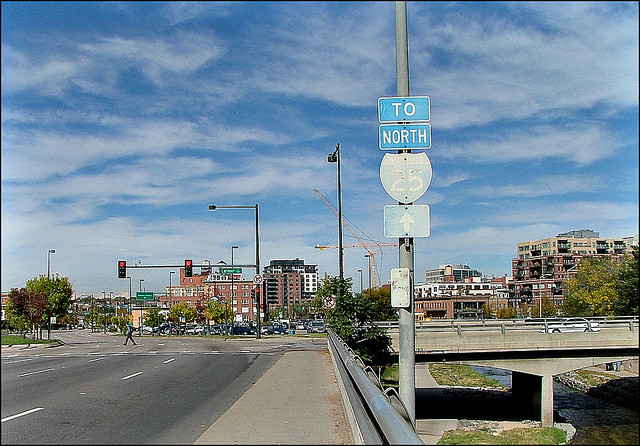Identify and read out the text in this image. TO NORTH 25 